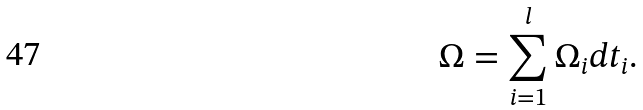<formula> <loc_0><loc_0><loc_500><loc_500>\Omega = \sum _ { i = 1 } ^ { l } \Omega _ { i } d t _ { i } .</formula> 